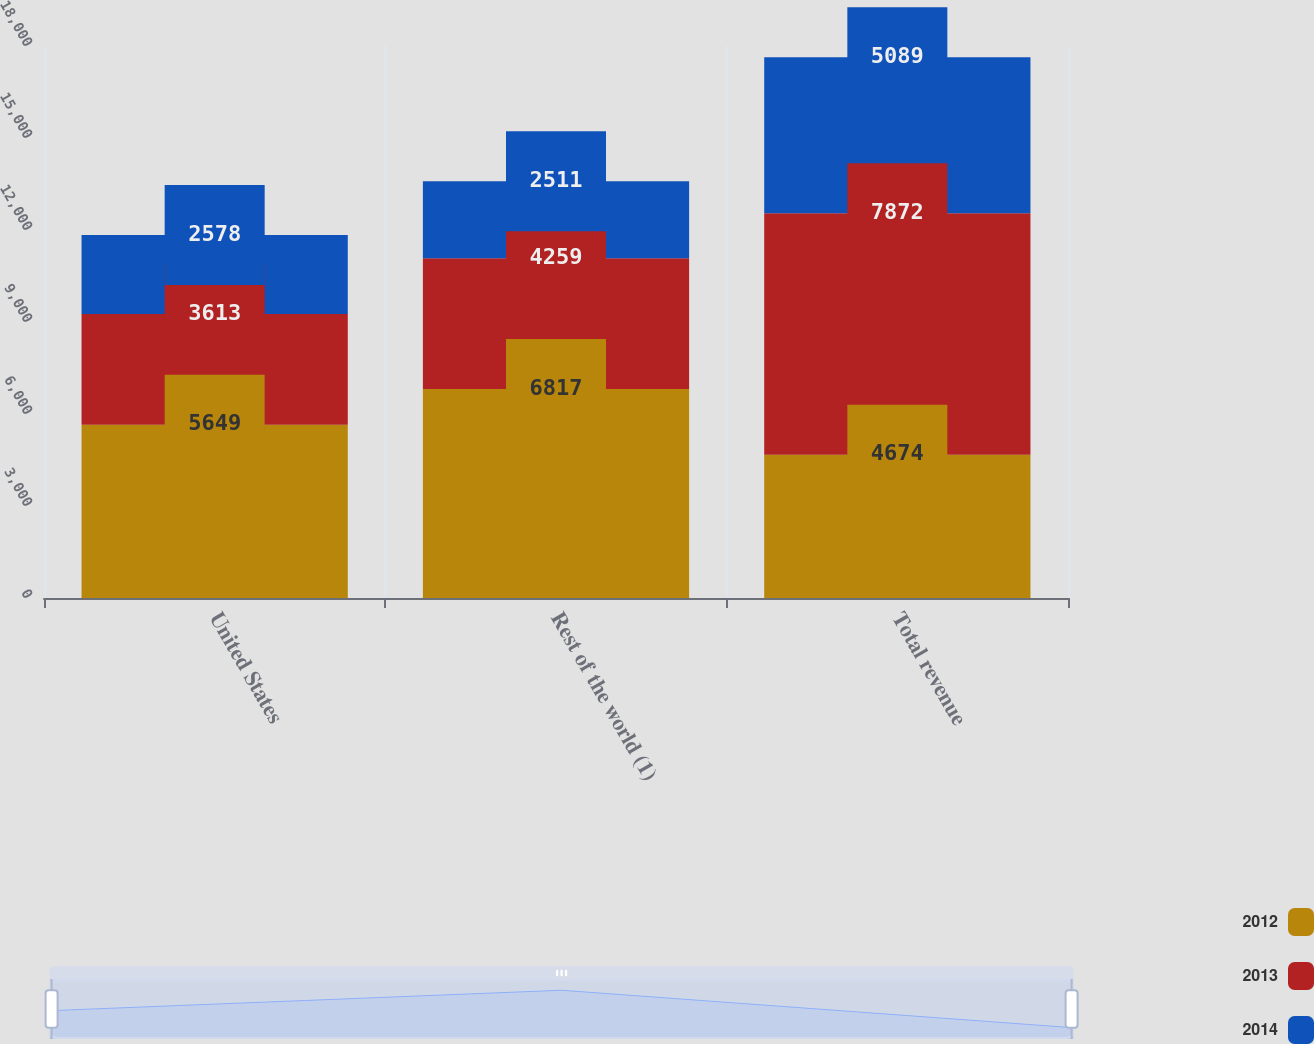<chart> <loc_0><loc_0><loc_500><loc_500><stacked_bar_chart><ecel><fcel>United States<fcel>Rest of the world (1)<fcel>Total revenue<nl><fcel>2012<fcel>5649<fcel>6817<fcel>4674<nl><fcel>2013<fcel>3613<fcel>4259<fcel>7872<nl><fcel>2014<fcel>2578<fcel>2511<fcel>5089<nl></chart> 